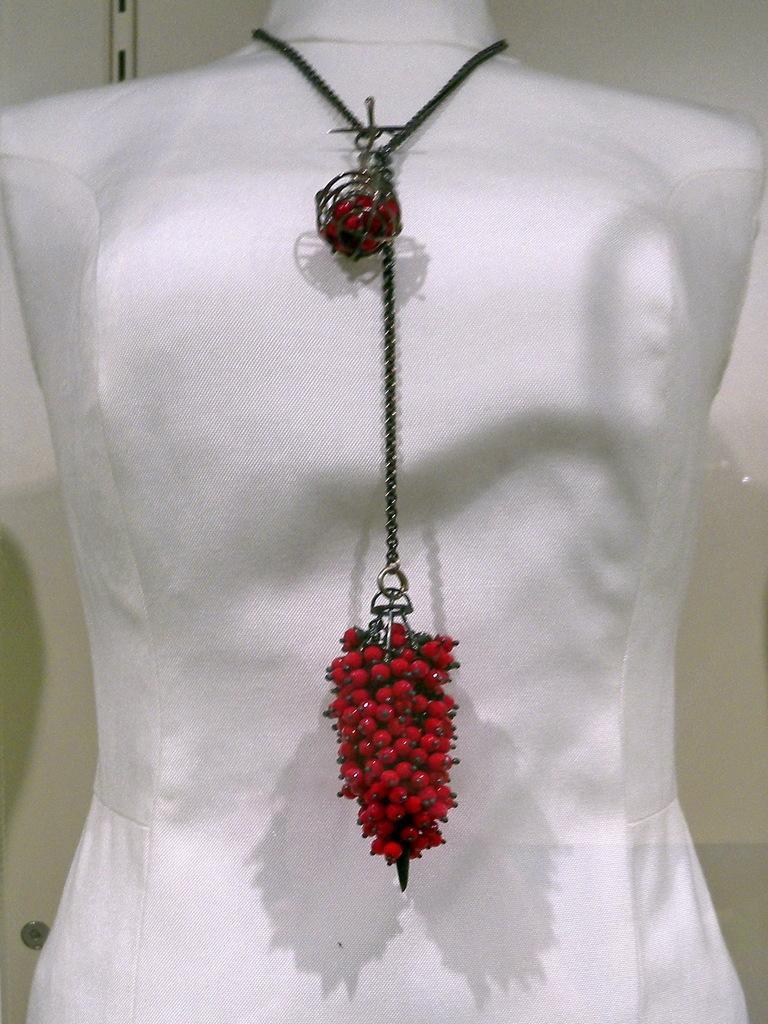In one or two sentences, can you explain what this image depicts? There is a chain which has a red color bottom is attached to a white color object. 